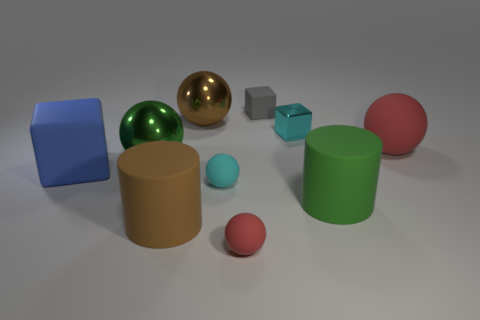Subtract all cyan spheres. How many spheres are left? 4 Subtract all large brown spheres. How many spheres are left? 4 Subtract all gray spheres. Subtract all green blocks. How many spheres are left? 5 Subtract all blocks. How many objects are left? 7 Subtract 1 cyan spheres. How many objects are left? 9 Subtract all small red rubber balls. Subtract all tiny matte balls. How many objects are left? 7 Add 6 cyan balls. How many cyan balls are left? 7 Add 2 small cyan shiny objects. How many small cyan shiny objects exist? 3 